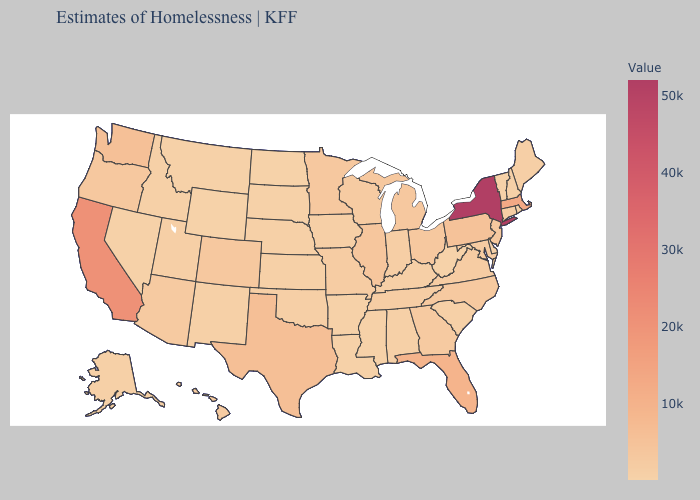Which states have the lowest value in the USA?
Keep it brief. North Dakota. Does Minnesota have the lowest value in the USA?
Answer briefly. No. Does Hawaii have a higher value than Florida?
Short answer required. No. Which states hav the highest value in the MidWest?
Concise answer only. Illinois. Among the states that border North Carolina , does Virginia have the highest value?
Concise answer only. No. Does New York have the highest value in the Northeast?
Keep it brief. Yes. Which states have the lowest value in the South?
Write a very short answer. West Virginia. 